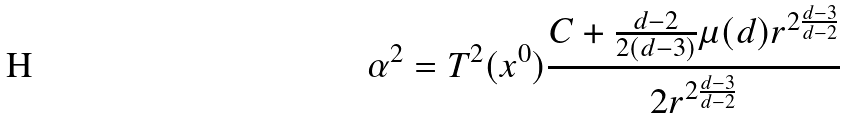Convert formula to latex. <formula><loc_0><loc_0><loc_500><loc_500>\alpha ^ { 2 } = T ^ { 2 } ( x ^ { 0 } ) \frac { C + \frac { d - 2 } { 2 ( d - 3 ) } \mu ( d ) r ^ { 2 \frac { d - 3 } { d - 2 } } } { 2 r ^ { 2 \frac { d - 3 } { d - 2 } } }</formula> 